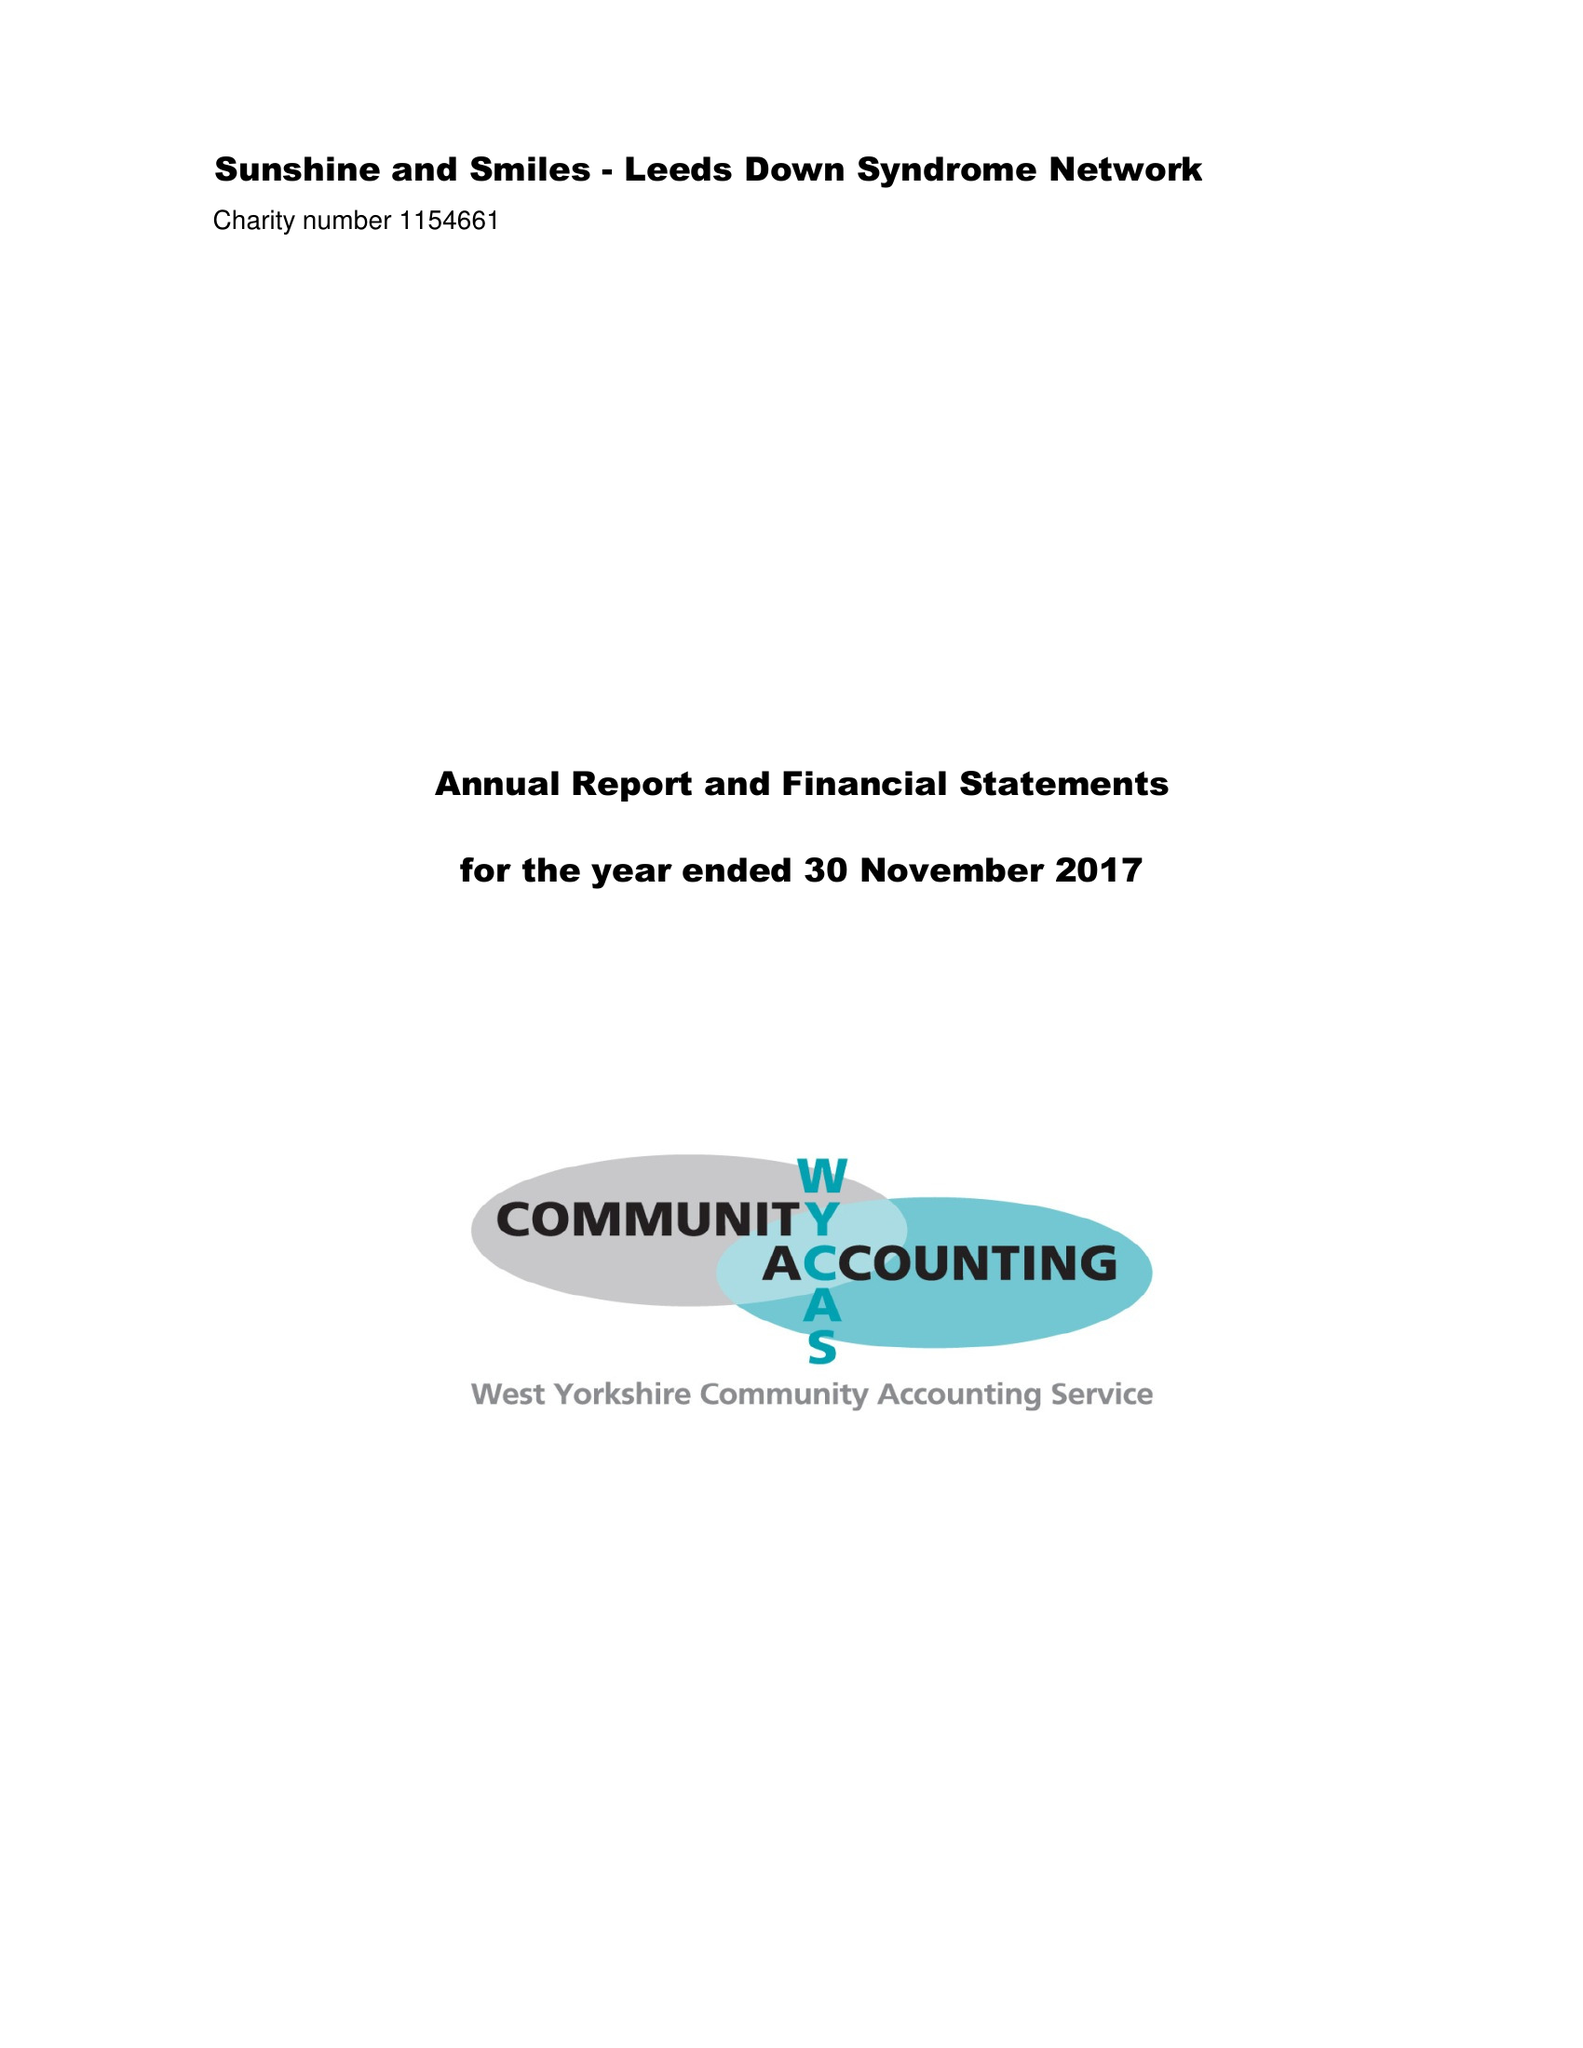What is the value for the income_annually_in_british_pounds?
Answer the question using a single word or phrase. 86801.00 